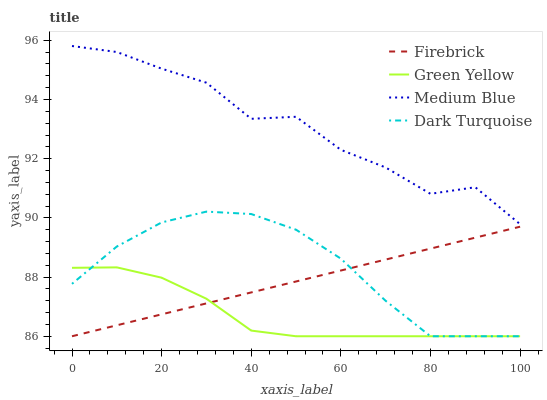Does Green Yellow have the minimum area under the curve?
Answer yes or no. Yes. Does Medium Blue have the maximum area under the curve?
Answer yes or no. Yes. Does Firebrick have the minimum area under the curve?
Answer yes or no. No. Does Firebrick have the maximum area under the curve?
Answer yes or no. No. Is Firebrick the smoothest?
Answer yes or no. Yes. Is Medium Blue the roughest?
Answer yes or no. Yes. Is Green Yellow the smoothest?
Answer yes or no. No. Is Green Yellow the roughest?
Answer yes or no. No. Does Dark Turquoise have the lowest value?
Answer yes or no. Yes. Does Medium Blue have the lowest value?
Answer yes or no. No. Does Medium Blue have the highest value?
Answer yes or no. Yes. Does Firebrick have the highest value?
Answer yes or no. No. Is Green Yellow less than Medium Blue?
Answer yes or no. Yes. Is Medium Blue greater than Green Yellow?
Answer yes or no. Yes. Does Firebrick intersect Dark Turquoise?
Answer yes or no. Yes. Is Firebrick less than Dark Turquoise?
Answer yes or no. No. Is Firebrick greater than Dark Turquoise?
Answer yes or no. No. Does Green Yellow intersect Medium Blue?
Answer yes or no. No. 